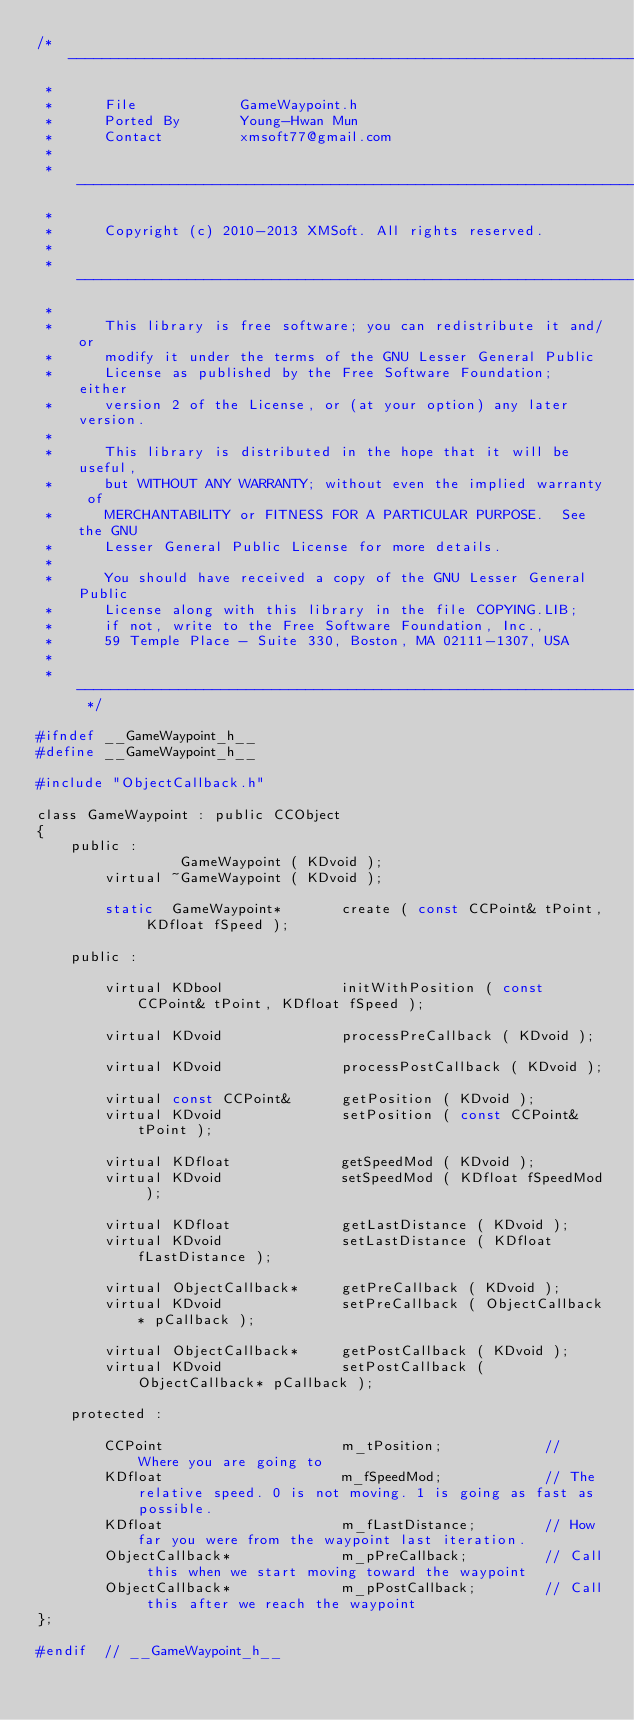<code> <loc_0><loc_0><loc_500><loc_500><_C_>/* --------------------------------------------------------------------------
 *
 *      File            GameWaypoint.h
 *      Ported By       Young-Hwan Mun
 *      Contact         xmsoft77@gmail.com 
 * 
 * --------------------------------------------------------------------------
 *      
 *      Copyright (c) 2010-2013 XMSoft. All rights reserved.
 * 
 * --------------------------------------------------------------------------
 * 
 *      This library is free software; you can redistribute it and/or
 *      modify it under the terms of the GNU Lesser General Public
 *      License as published by the Free Software Foundation; either
 *      version 2 of the License, or (at your option) any later version.
 * 
 *      This library is distributed in the hope that it will be useful,
 *      but WITHOUT ANY WARRANTY; without even the implied warranty of
 *      MERCHANTABILITY or FITNESS FOR A PARTICULAR PURPOSE.  See the GNU
 *      Lesser General Public License for more details.
 * 
 *      You should have received a copy of the GNU Lesser General Public
 *      License along with this library in the file COPYING.LIB;
 *      if not, write to the Free Software Foundation, Inc.,
 *      59 Temple Place - Suite 330, Boston, MA 02111-1307, USA
 *
 * -------------------------------------------------------------------------- */ 

#ifndef __GameWaypoint_h__
#define __GameWaypoint_h__

#include "ObjectCallback.h"

class GameWaypoint : public CCObject
{
	public :
				 GameWaypoint ( KDvoid );
		virtual ~GameWaypoint ( KDvoid );

		static  GameWaypoint*		create ( const CCPoint& tPoint, KDfloat fSpeed );

	public :

		virtual KDbool				initWithPosition ( const CCPoint& tPoint, KDfloat fSpeed );

		virtual KDvoid				processPreCallback ( KDvoid );

		virtual KDvoid				processPostCallback ( KDvoid );

		virtual const CCPoint&		getPosition ( KDvoid );
		virtual KDvoid				setPosition ( const CCPoint& tPoint );

		virtual KDfloat				getSpeedMod ( KDvoid );
		virtual KDvoid				setSpeedMod ( KDfloat fSpeedMod );

		virtual KDfloat				getLastDistance ( KDvoid );
		virtual KDvoid				setLastDistance ( KDfloat fLastDistance );

		virtual ObjectCallback*		getPreCallback ( KDvoid );
		virtual KDvoid				setPreCallback ( ObjectCallback* pCallback );

		virtual ObjectCallback*		getPostCallback ( KDvoid );
		virtual KDvoid				setPostCallback ( ObjectCallback* pCallback );

	protected :

		CCPoint						m_tPosition;			// Where you are going to
		KDfloat						m_fSpeedMod;			// The relative speed. 0 is not moving. 1 is going as fast as possible.
		KDfloat						m_fLastDistance;		// How far you were from the waypoint last iteration.
		ObjectCallback*				m_pPreCallback;			// Call this when we start moving toward the waypoint
		ObjectCallback*				m_pPostCallback;		// Call this after we reach the waypoint
};

#endif	// __GameWaypoint_h__
</code> 